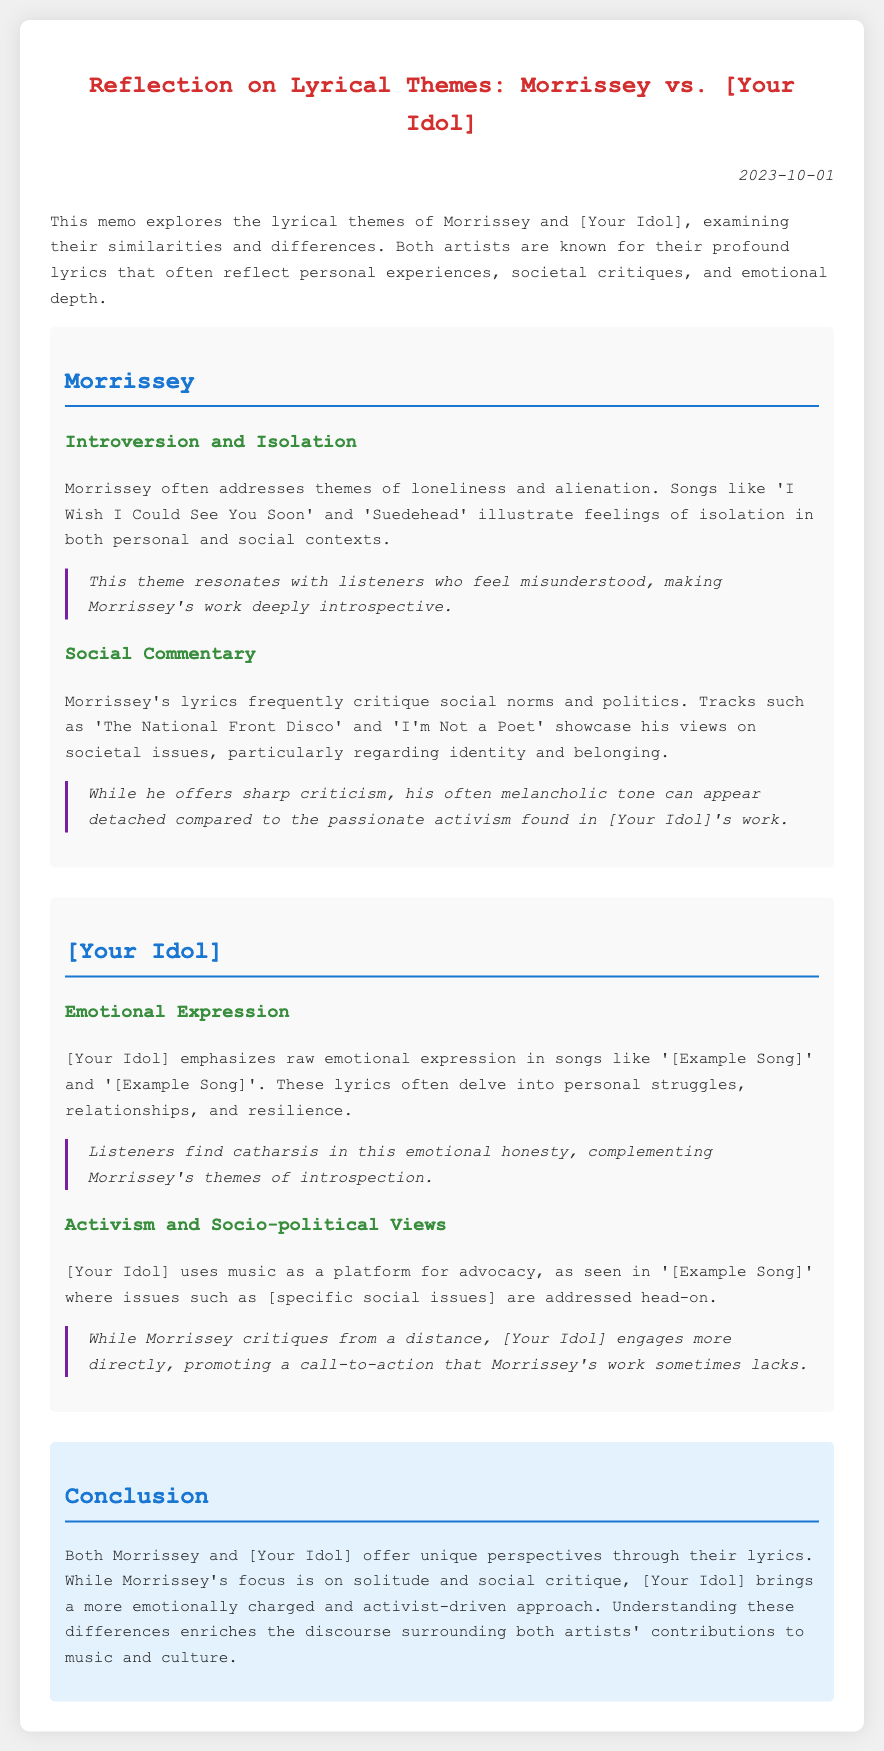what is the title of the memo? The title is presented at the top of the document and reflects the main theme, comparing the two artists.
Answer: Reflection on Lyrical Themes: Morrissey vs. [Your Idol] who is the first artist discussed in the memo? The memo starts with a section that focuses on one artist before discussing the other.
Answer: Morrissey how does Morrissey address the theme of isolation? The document mentions specific songs that highlight this theme.
Answer: 'I Wish I Could See You Soon' and 'Suedehead' which theme is highlighted for [Your Idol]? The memo states multiple themes for both artists, one of which stands out for [Your Idol].
Answer: Emotional Expression what is a notable divergence in the social commentary of both artists? The document makes a clear distinction in the approach to social issues between the two artists.
Answer: Morrissey critiques from a distance; [Your Idol] engages directly how does the memo describe the emotional honesty in [Your Idol]'s lyrics? There is a description of how listeners respond to the emotional content of [Your Idol]'s work.
Answer: Listeners find catharsis what date is indicated on the memo? The date of the memo is included for reference.
Answer: 2023-10-01 what is concluded about the difference in approach between the two artists? The final section summarizes the overall perspectives both artists offer through their lyrical themes.
Answer: Morrissey's focus is on solitude and social critique; [Your Idol] brings a more emotionally charged and activist-driven approach 